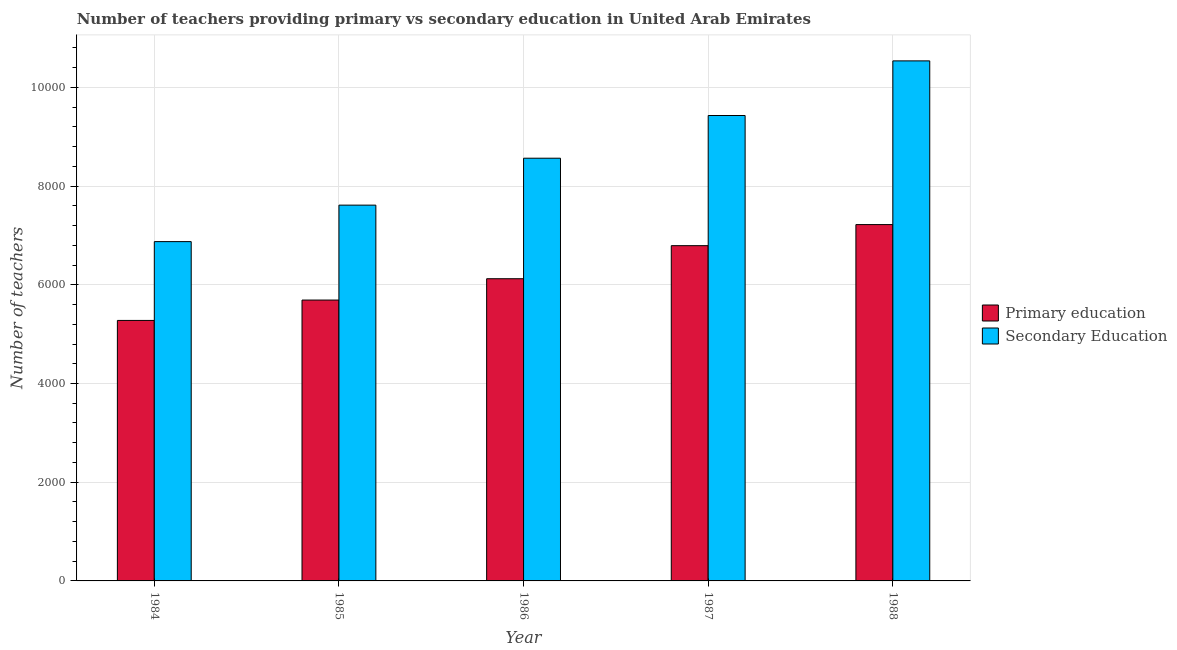How many groups of bars are there?
Give a very brief answer. 5. Are the number of bars per tick equal to the number of legend labels?
Provide a succinct answer. Yes. Are the number of bars on each tick of the X-axis equal?
Give a very brief answer. Yes. How many bars are there on the 5th tick from the left?
Ensure brevity in your answer.  2. How many bars are there on the 4th tick from the right?
Keep it short and to the point. 2. What is the label of the 1st group of bars from the left?
Offer a very short reply. 1984. What is the number of secondary teachers in 1984?
Offer a very short reply. 6875. Across all years, what is the maximum number of primary teachers?
Your answer should be very brief. 7220. Across all years, what is the minimum number of primary teachers?
Offer a terse response. 5278. In which year was the number of primary teachers maximum?
Your answer should be compact. 1988. What is the total number of secondary teachers in the graph?
Your response must be concise. 4.30e+04. What is the difference between the number of primary teachers in 1986 and that in 1988?
Keep it short and to the point. -1097. What is the difference between the number of primary teachers in 1988 and the number of secondary teachers in 1985?
Your answer should be very brief. 1529. What is the average number of primary teachers per year?
Ensure brevity in your answer.  6221. In the year 1987, what is the difference between the number of secondary teachers and number of primary teachers?
Make the answer very short. 0. In how many years, is the number of secondary teachers greater than 4400?
Offer a very short reply. 5. What is the ratio of the number of primary teachers in 1984 to that in 1986?
Provide a short and direct response. 0.86. Is the difference between the number of secondary teachers in 1985 and 1988 greater than the difference between the number of primary teachers in 1985 and 1988?
Provide a short and direct response. No. What is the difference between the highest and the second highest number of secondary teachers?
Make the answer very short. 1107. What is the difference between the highest and the lowest number of primary teachers?
Offer a terse response. 1942. In how many years, is the number of primary teachers greater than the average number of primary teachers taken over all years?
Your response must be concise. 2. What does the 1st bar from the left in 1988 represents?
Your response must be concise. Primary education. What does the 2nd bar from the right in 1987 represents?
Make the answer very short. Primary education. How many bars are there?
Your answer should be very brief. 10. Are all the bars in the graph horizontal?
Offer a terse response. No. How many years are there in the graph?
Your response must be concise. 5. Are the values on the major ticks of Y-axis written in scientific E-notation?
Offer a very short reply. No. Where does the legend appear in the graph?
Your response must be concise. Center right. How many legend labels are there?
Provide a succinct answer. 2. What is the title of the graph?
Your answer should be very brief. Number of teachers providing primary vs secondary education in United Arab Emirates. What is the label or title of the X-axis?
Make the answer very short. Year. What is the label or title of the Y-axis?
Your answer should be compact. Number of teachers. What is the Number of teachers in Primary education in 1984?
Your answer should be very brief. 5278. What is the Number of teachers of Secondary Education in 1984?
Ensure brevity in your answer.  6875. What is the Number of teachers of Primary education in 1985?
Offer a terse response. 5691. What is the Number of teachers in Secondary Education in 1985?
Provide a succinct answer. 7614. What is the Number of teachers of Primary education in 1986?
Your response must be concise. 6123. What is the Number of teachers of Secondary Education in 1986?
Provide a succinct answer. 8565. What is the Number of teachers in Primary education in 1987?
Make the answer very short. 6793. What is the Number of teachers in Secondary Education in 1987?
Your response must be concise. 9430. What is the Number of teachers of Primary education in 1988?
Offer a terse response. 7220. What is the Number of teachers in Secondary Education in 1988?
Your response must be concise. 1.05e+04. Across all years, what is the maximum Number of teachers in Primary education?
Make the answer very short. 7220. Across all years, what is the maximum Number of teachers in Secondary Education?
Your answer should be very brief. 1.05e+04. Across all years, what is the minimum Number of teachers of Primary education?
Give a very brief answer. 5278. Across all years, what is the minimum Number of teachers in Secondary Education?
Offer a very short reply. 6875. What is the total Number of teachers of Primary education in the graph?
Give a very brief answer. 3.11e+04. What is the total Number of teachers in Secondary Education in the graph?
Your response must be concise. 4.30e+04. What is the difference between the Number of teachers of Primary education in 1984 and that in 1985?
Ensure brevity in your answer.  -413. What is the difference between the Number of teachers in Secondary Education in 1984 and that in 1985?
Provide a short and direct response. -739. What is the difference between the Number of teachers of Primary education in 1984 and that in 1986?
Your answer should be very brief. -845. What is the difference between the Number of teachers of Secondary Education in 1984 and that in 1986?
Offer a terse response. -1690. What is the difference between the Number of teachers of Primary education in 1984 and that in 1987?
Give a very brief answer. -1515. What is the difference between the Number of teachers in Secondary Education in 1984 and that in 1987?
Make the answer very short. -2555. What is the difference between the Number of teachers in Primary education in 1984 and that in 1988?
Make the answer very short. -1942. What is the difference between the Number of teachers of Secondary Education in 1984 and that in 1988?
Keep it short and to the point. -3662. What is the difference between the Number of teachers of Primary education in 1985 and that in 1986?
Provide a short and direct response. -432. What is the difference between the Number of teachers of Secondary Education in 1985 and that in 1986?
Give a very brief answer. -951. What is the difference between the Number of teachers of Primary education in 1985 and that in 1987?
Ensure brevity in your answer.  -1102. What is the difference between the Number of teachers of Secondary Education in 1985 and that in 1987?
Your response must be concise. -1816. What is the difference between the Number of teachers in Primary education in 1985 and that in 1988?
Offer a terse response. -1529. What is the difference between the Number of teachers in Secondary Education in 1985 and that in 1988?
Keep it short and to the point. -2923. What is the difference between the Number of teachers in Primary education in 1986 and that in 1987?
Ensure brevity in your answer.  -670. What is the difference between the Number of teachers of Secondary Education in 1986 and that in 1987?
Your answer should be compact. -865. What is the difference between the Number of teachers in Primary education in 1986 and that in 1988?
Offer a very short reply. -1097. What is the difference between the Number of teachers in Secondary Education in 1986 and that in 1988?
Make the answer very short. -1972. What is the difference between the Number of teachers of Primary education in 1987 and that in 1988?
Ensure brevity in your answer.  -427. What is the difference between the Number of teachers in Secondary Education in 1987 and that in 1988?
Keep it short and to the point. -1107. What is the difference between the Number of teachers of Primary education in 1984 and the Number of teachers of Secondary Education in 1985?
Make the answer very short. -2336. What is the difference between the Number of teachers of Primary education in 1984 and the Number of teachers of Secondary Education in 1986?
Your answer should be very brief. -3287. What is the difference between the Number of teachers in Primary education in 1984 and the Number of teachers in Secondary Education in 1987?
Give a very brief answer. -4152. What is the difference between the Number of teachers of Primary education in 1984 and the Number of teachers of Secondary Education in 1988?
Make the answer very short. -5259. What is the difference between the Number of teachers of Primary education in 1985 and the Number of teachers of Secondary Education in 1986?
Give a very brief answer. -2874. What is the difference between the Number of teachers of Primary education in 1985 and the Number of teachers of Secondary Education in 1987?
Keep it short and to the point. -3739. What is the difference between the Number of teachers of Primary education in 1985 and the Number of teachers of Secondary Education in 1988?
Your answer should be very brief. -4846. What is the difference between the Number of teachers in Primary education in 1986 and the Number of teachers in Secondary Education in 1987?
Offer a very short reply. -3307. What is the difference between the Number of teachers in Primary education in 1986 and the Number of teachers in Secondary Education in 1988?
Give a very brief answer. -4414. What is the difference between the Number of teachers in Primary education in 1987 and the Number of teachers in Secondary Education in 1988?
Provide a short and direct response. -3744. What is the average Number of teachers of Primary education per year?
Make the answer very short. 6221. What is the average Number of teachers of Secondary Education per year?
Keep it short and to the point. 8604.2. In the year 1984, what is the difference between the Number of teachers in Primary education and Number of teachers in Secondary Education?
Your response must be concise. -1597. In the year 1985, what is the difference between the Number of teachers in Primary education and Number of teachers in Secondary Education?
Your answer should be very brief. -1923. In the year 1986, what is the difference between the Number of teachers of Primary education and Number of teachers of Secondary Education?
Provide a succinct answer. -2442. In the year 1987, what is the difference between the Number of teachers of Primary education and Number of teachers of Secondary Education?
Ensure brevity in your answer.  -2637. In the year 1988, what is the difference between the Number of teachers in Primary education and Number of teachers in Secondary Education?
Offer a terse response. -3317. What is the ratio of the Number of teachers of Primary education in 1984 to that in 1985?
Make the answer very short. 0.93. What is the ratio of the Number of teachers in Secondary Education in 1984 to that in 1985?
Offer a very short reply. 0.9. What is the ratio of the Number of teachers of Primary education in 1984 to that in 1986?
Ensure brevity in your answer.  0.86. What is the ratio of the Number of teachers of Secondary Education in 1984 to that in 1986?
Offer a terse response. 0.8. What is the ratio of the Number of teachers of Primary education in 1984 to that in 1987?
Your response must be concise. 0.78. What is the ratio of the Number of teachers of Secondary Education in 1984 to that in 1987?
Give a very brief answer. 0.73. What is the ratio of the Number of teachers of Primary education in 1984 to that in 1988?
Provide a short and direct response. 0.73. What is the ratio of the Number of teachers in Secondary Education in 1984 to that in 1988?
Provide a short and direct response. 0.65. What is the ratio of the Number of teachers of Primary education in 1985 to that in 1986?
Give a very brief answer. 0.93. What is the ratio of the Number of teachers in Secondary Education in 1985 to that in 1986?
Your response must be concise. 0.89. What is the ratio of the Number of teachers in Primary education in 1985 to that in 1987?
Your response must be concise. 0.84. What is the ratio of the Number of teachers of Secondary Education in 1985 to that in 1987?
Offer a very short reply. 0.81. What is the ratio of the Number of teachers in Primary education in 1985 to that in 1988?
Your answer should be very brief. 0.79. What is the ratio of the Number of teachers of Secondary Education in 1985 to that in 1988?
Make the answer very short. 0.72. What is the ratio of the Number of teachers of Primary education in 1986 to that in 1987?
Offer a terse response. 0.9. What is the ratio of the Number of teachers of Secondary Education in 1986 to that in 1987?
Provide a succinct answer. 0.91. What is the ratio of the Number of teachers of Primary education in 1986 to that in 1988?
Your response must be concise. 0.85. What is the ratio of the Number of teachers in Secondary Education in 1986 to that in 1988?
Your response must be concise. 0.81. What is the ratio of the Number of teachers in Primary education in 1987 to that in 1988?
Offer a very short reply. 0.94. What is the ratio of the Number of teachers in Secondary Education in 1987 to that in 1988?
Your answer should be compact. 0.89. What is the difference between the highest and the second highest Number of teachers of Primary education?
Your response must be concise. 427. What is the difference between the highest and the second highest Number of teachers in Secondary Education?
Provide a short and direct response. 1107. What is the difference between the highest and the lowest Number of teachers in Primary education?
Provide a short and direct response. 1942. What is the difference between the highest and the lowest Number of teachers in Secondary Education?
Provide a succinct answer. 3662. 